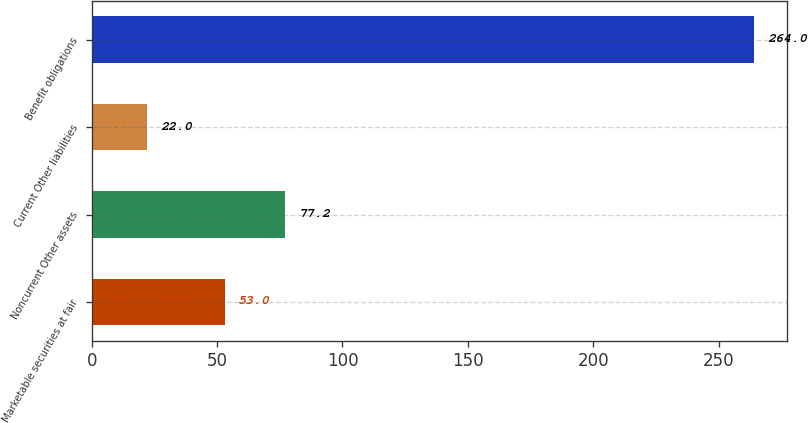Convert chart to OTSL. <chart><loc_0><loc_0><loc_500><loc_500><bar_chart><fcel>Marketable securities at fair<fcel>Noncurrent Other assets<fcel>Current Other liabilities<fcel>Benefit obligations<nl><fcel>53<fcel>77.2<fcel>22<fcel>264<nl></chart> 